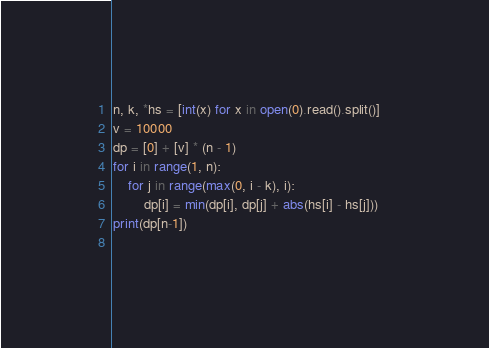Convert code to text. <code><loc_0><loc_0><loc_500><loc_500><_Python_>n, k, *hs = [int(x) for x in open(0).read().split()]   
v = 10000                                              
dp = [0] + [v] * (n - 1)                               
for i in range(1, n):                                  
    for j in range(max(0, i - k), i):                  
        dp[i] = min(dp[i], dp[j] + abs(hs[i] - hs[j])) 
print(dp[n-1])                                         
                                                       </code> 